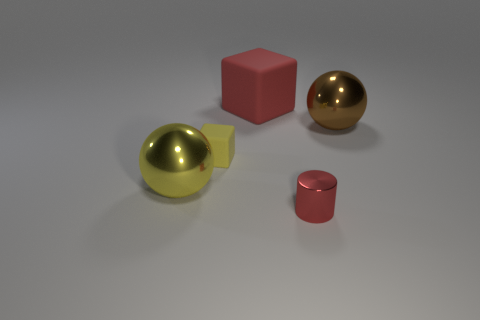Add 2 large red matte blocks. How many objects exist? 7 Subtract all cylinders. How many objects are left? 4 Add 2 small red cylinders. How many small red cylinders exist? 3 Subtract 0 blue balls. How many objects are left? 5 Subtract all tiny metallic objects. Subtract all red shiny cylinders. How many objects are left? 3 Add 2 yellow balls. How many yellow balls are left? 3 